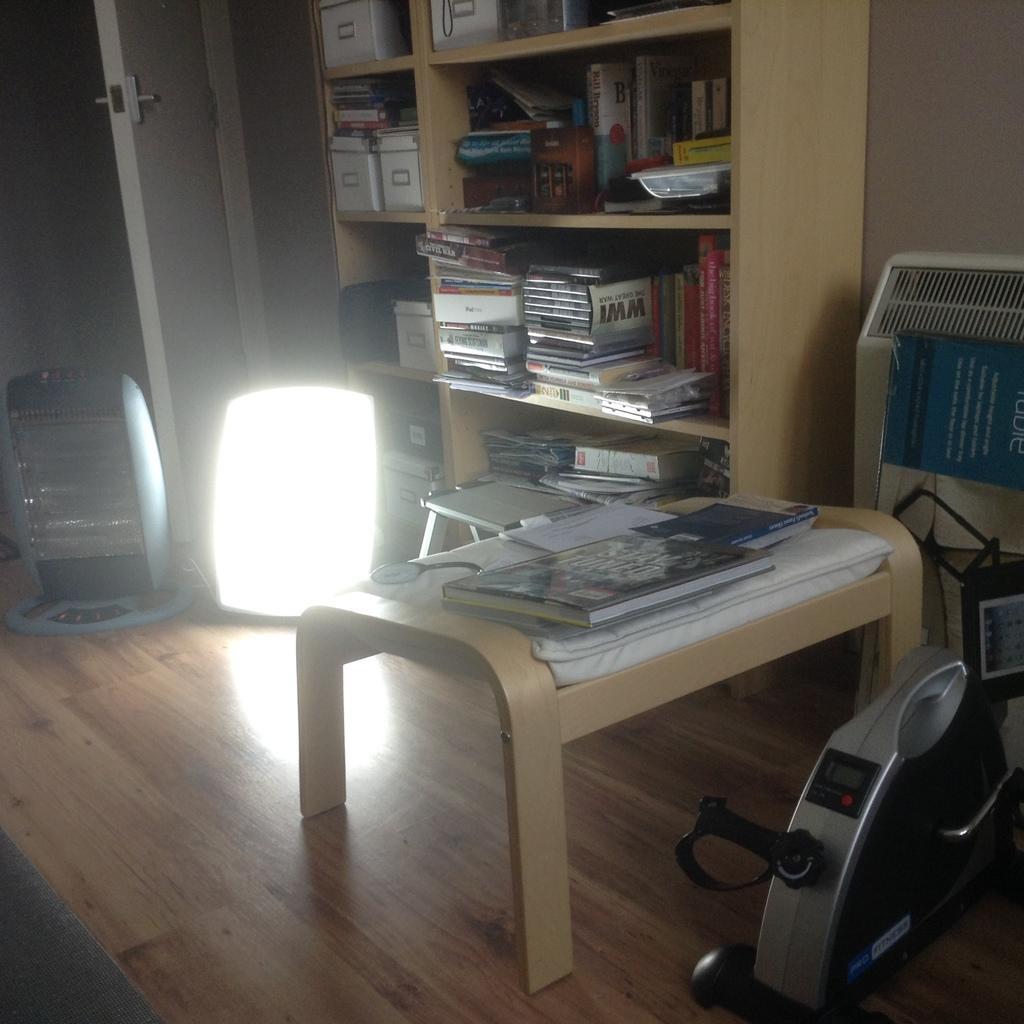Can you describe this image briefly? In a room there is a table. On the table there are some books. In the cupboard there are many books in the racks. And to the door there are two lights. And to the right corner there is a machine. 